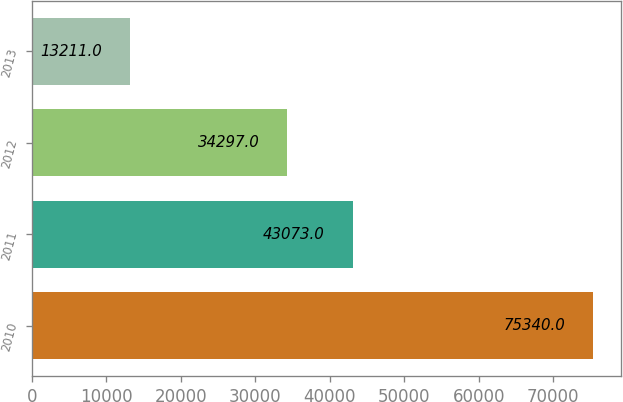Convert chart to OTSL. <chart><loc_0><loc_0><loc_500><loc_500><bar_chart><fcel>2010<fcel>2011<fcel>2012<fcel>2013<nl><fcel>75340<fcel>43073<fcel>34297<fcel>13211<nl></chart> 